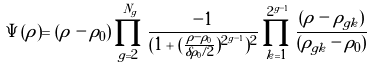<formula> <loc_0><loc_0><loc_500><loc_500>\Psi ( \rho ) = ( \rho - \rho _ { 0 } ) \, \prod _ { g = 2 } ^ { N _ { g } } \frac { - 1 } { ( 1 + ( \frac { \rho - \rho _ { 0 } } { \delta \rho _ { 0 } / 2 } ) ^ { 2 ^ { g - 1 } } ) ^ { 2 } } \prod _ { k = 1 } ^ { 2 ^ { g - 1 } } \frac { ( \rho - \rho _ { g k } ) } { ( \rho _ { g k } - \rho _ { 0 } ) }</formula> 